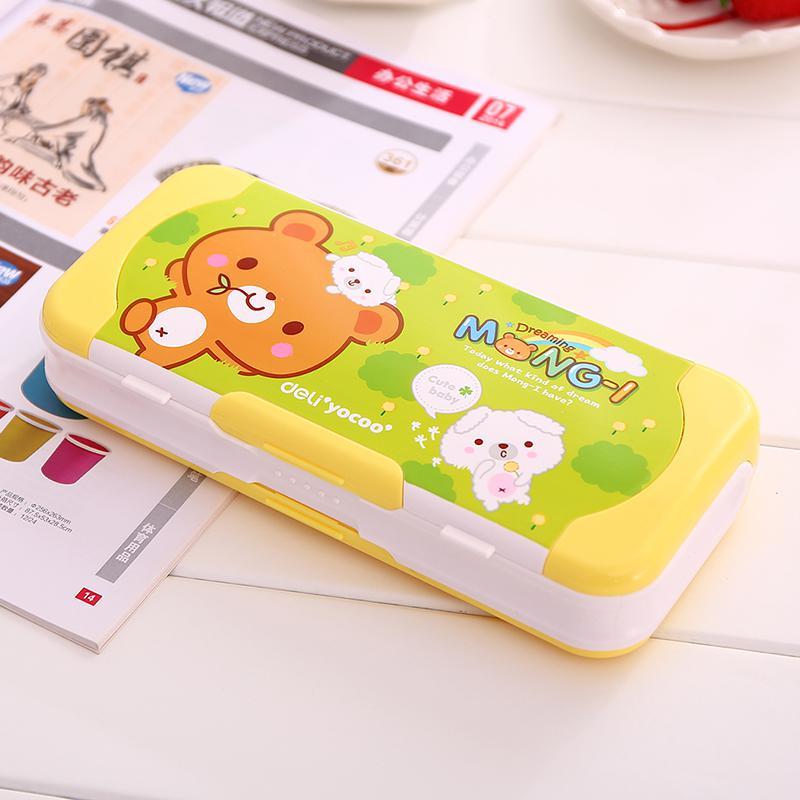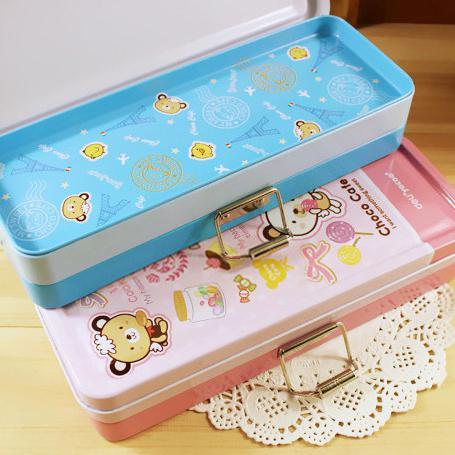The first image is the image on the left, the second image is the image on the right. For the images shown, is this caption "At least one pencil case has a brown bear on it." true? Answer yes or no. Yes. The first image is the image on the left, the second image is the image on the right. For the images displayed, is the sentence "At least one of the pencil cases has a brown cartoon bear on it." factually correct? Answer yes or no. Yes. 